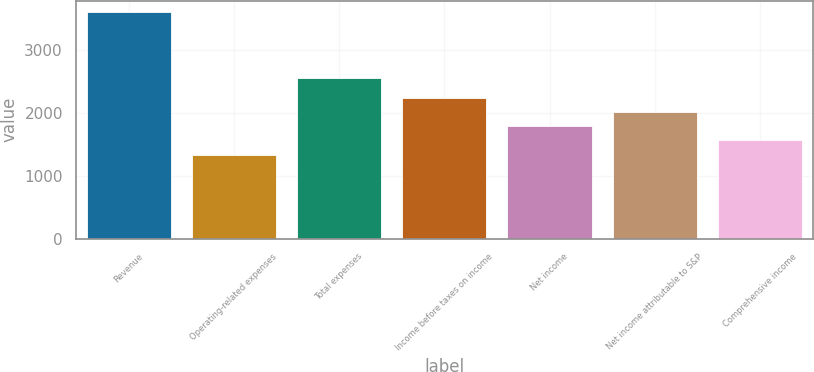Convert chart. <chart><loc_0><loc_0><loc_500><loc_500><bar_chart><fcel>Revenue<fcel>Operating-related expenses<fcel>Total expenses<fcel>Income before taxes on income<fcel>Net income<fcel>Net income attributable to S&P<fcel>Comprehensive income<nl><fcel>3607<fcel>1335<fcel>2556<fcel>2244.6<fcel>1790.2<fcel>2017.4<fcel>1563<nl></chart> 